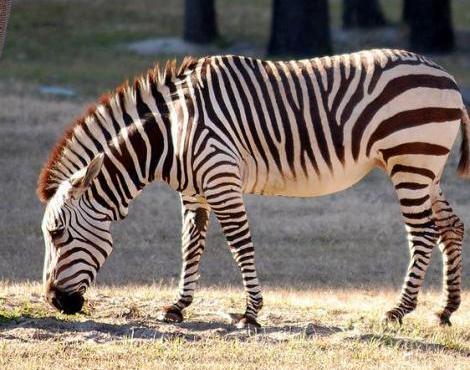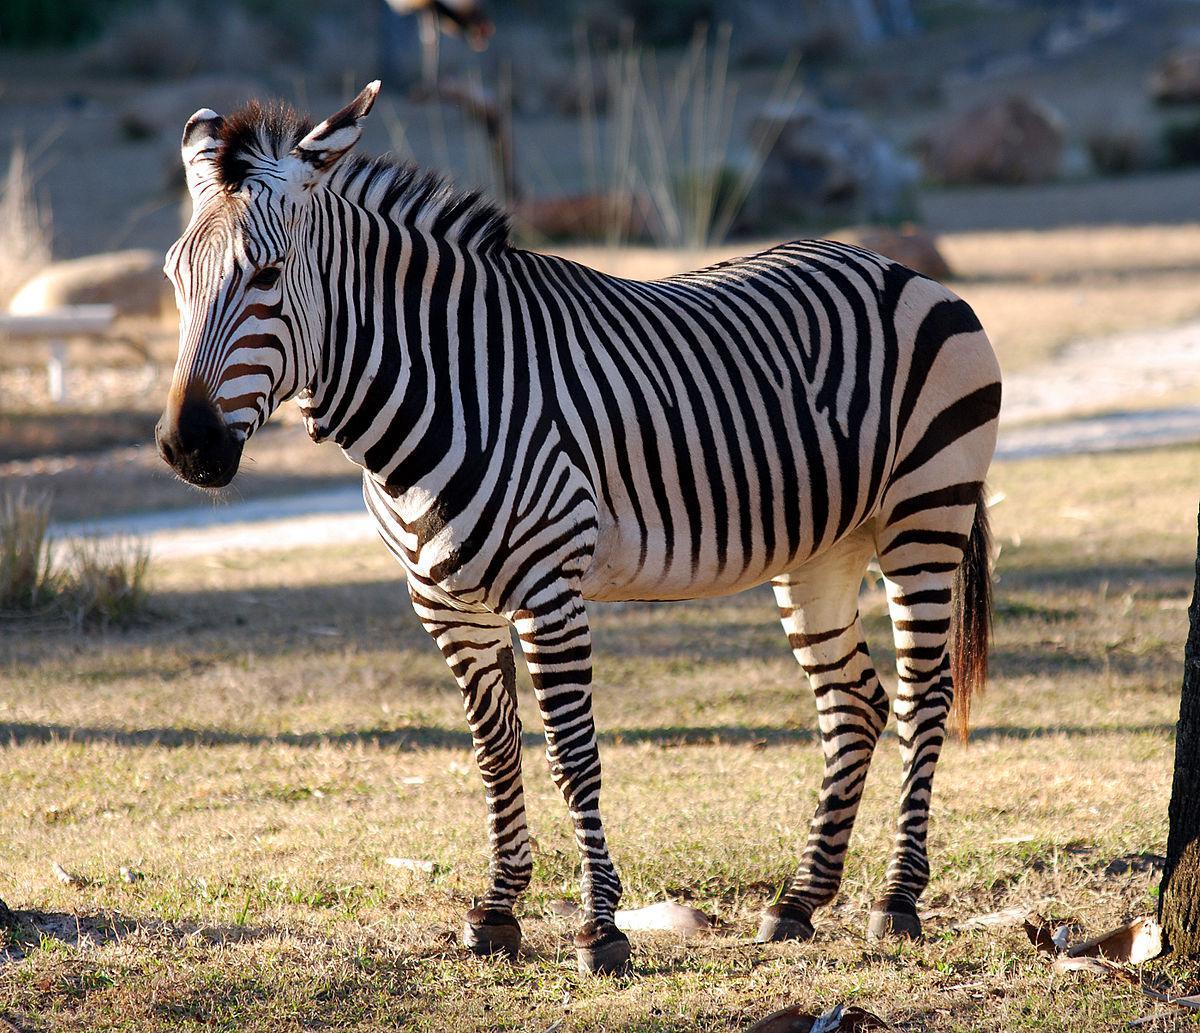The first image is the image on the left, the second image is the image on the right. For the images displayed, is the sentence "There is a single zebra in at least one of the images." factually correct? Answer yes or no. Yes. The first image is the image on the left, the second image is the image on the right. For the images displayed, is the sentence "In at least one image there is a baby zebra standing in front an adult zebra." factually correct? Answer yes or no. No. 